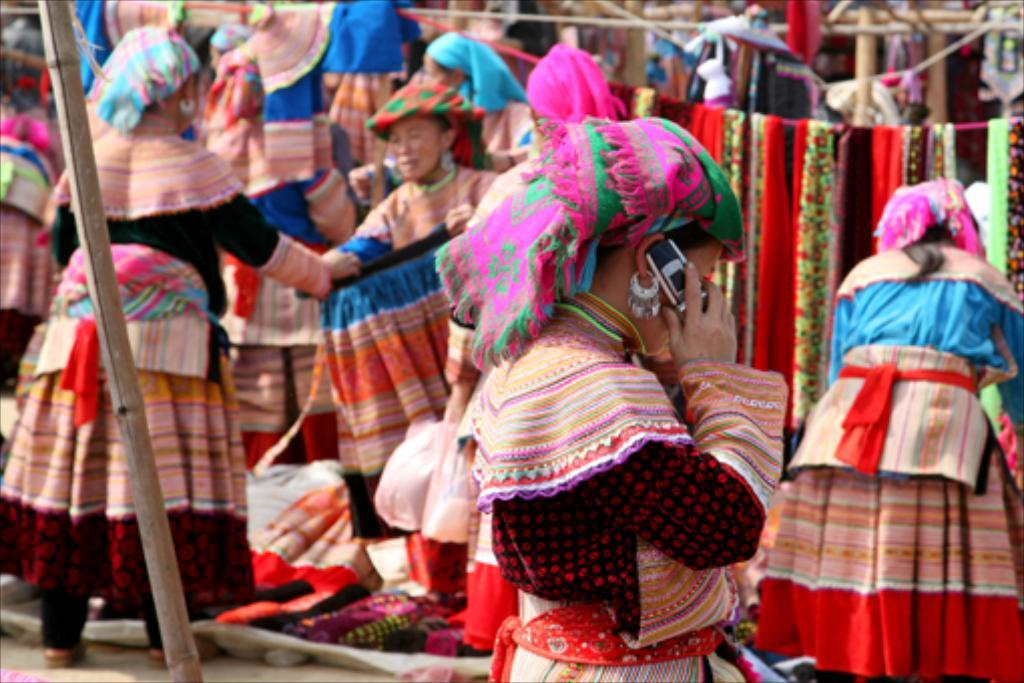How many people are in the image? There are people in the image, but the exact number is not specified. What is the woman holding in the image? The woman is holding a mobile in the image. What type of material is the wooden pole made of? The wooden pole is made of wood, as indicated by the fact. What items are related to clothing in the image? Clothes are present in the image. What type of cord-like objects are visible in the image? Ropes are visible in the image. What type of grain is being harvested by the snail in the image? There is no snail or grain present in the image. Can you describe the veins of the woman holding the mobile in the image? The facts provided do not mention any veins or the woman's physical appearance, so it is not possible to describe her veins. 